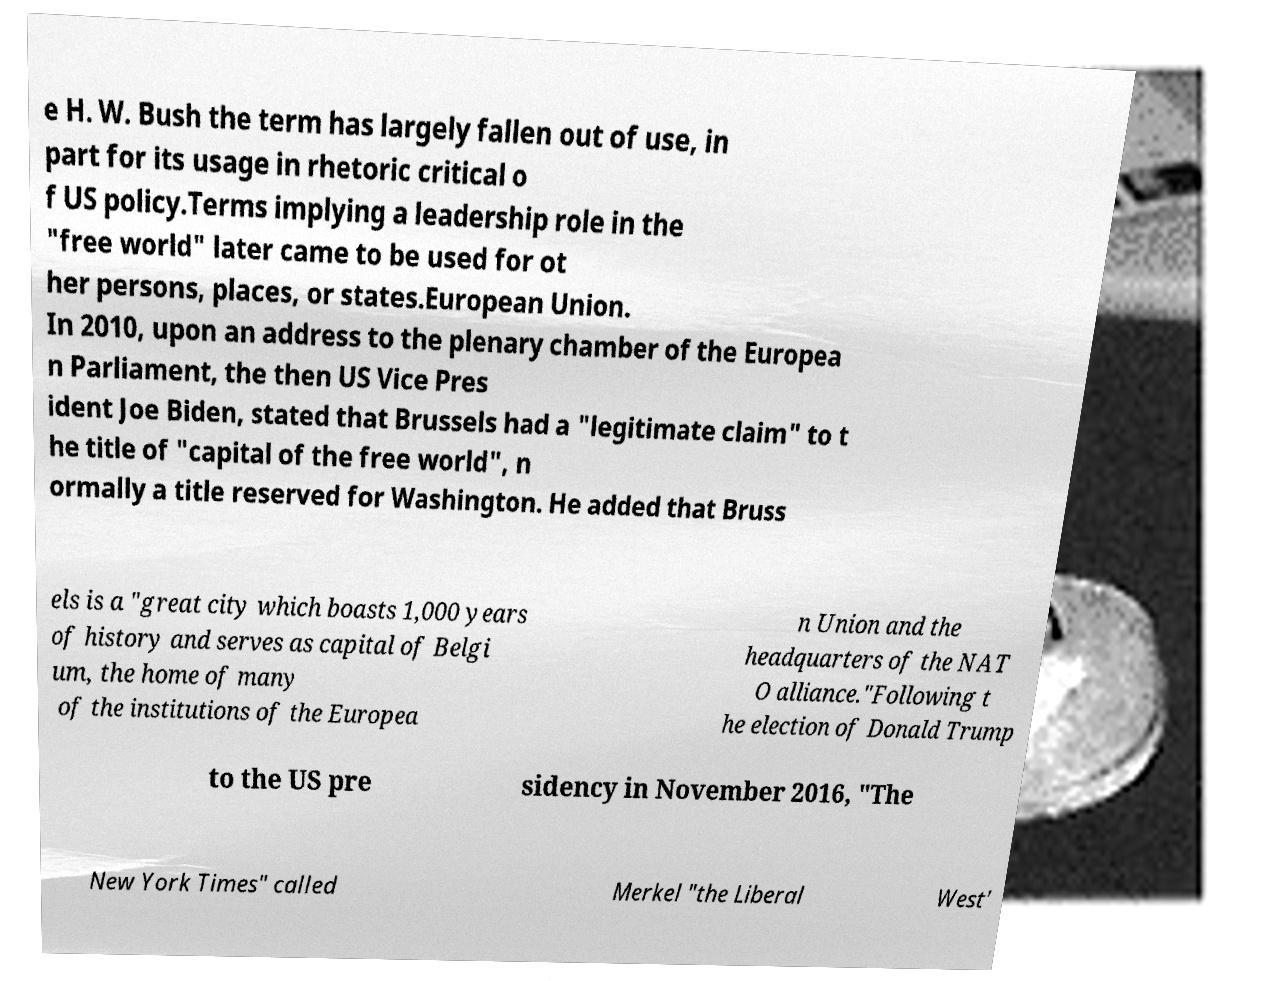Can you read and provide the text displayed in the image?This photo seems to have some interesting text. Can you extract and type it out for me? e H. W. Bush the term has largely fallen out of use, in part for its usage in rhetoric critical o f US policy.Terms implying a leadership role in the "free world" later came to be used for ot her persons, places, or states.European Union. In 2010, upon an address to the plenary chamber of the Europea n Parliament, the then US Vice Pres ident Joe Biden, stated that Brussels had a "legitimate claim" to t he title of "capital of the free world", n ormally a title reserved for Washington. He added that Bruss els is a "great city which boasts 1,000 years of history and serves as capital of Belgi um, the home of many of the institutions of the Europea n Union and the headquarters of the NAT O alliance."Following t he election of Donald Trump to the US pre sidency in November 2016, "The New York Times" called Merkel "the Liberal West' 